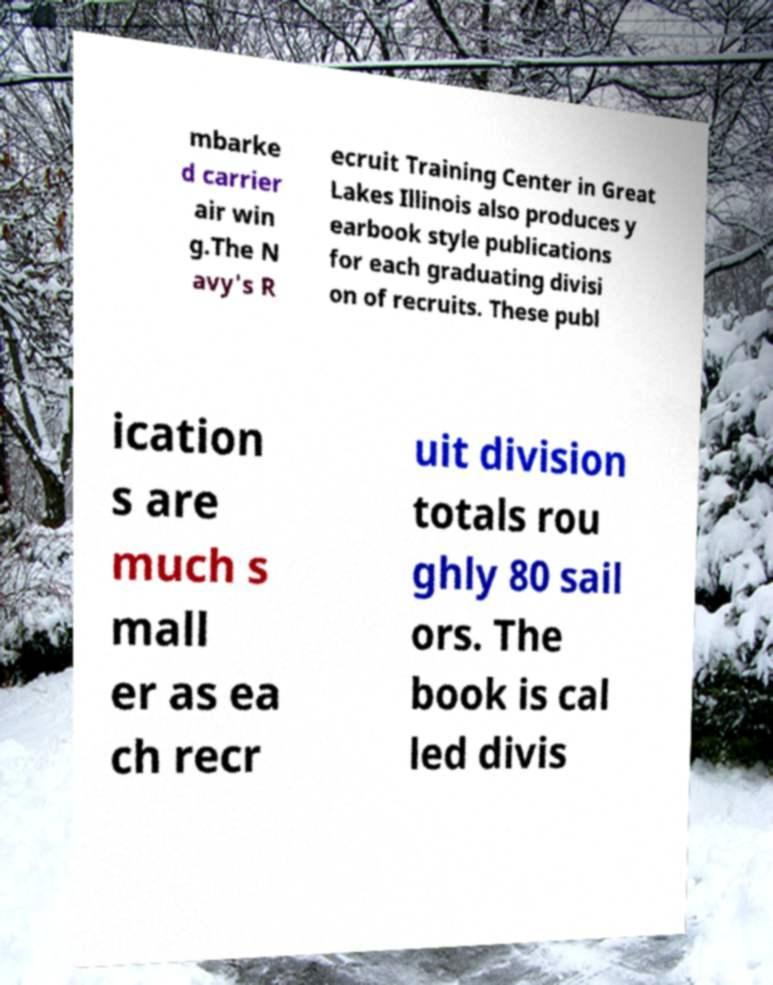Please identify and transcribe the text found in this image. mbarke d carrier air win g.The N avy's R ecruit Training Center in Great Lakes Illinois also produces y earbook style publications for each graduating divisi on of recruits. These publ ication s are much s mall er as ea ch recr uit division totals rou ghly 80 sail ors. The book is cal led divis 